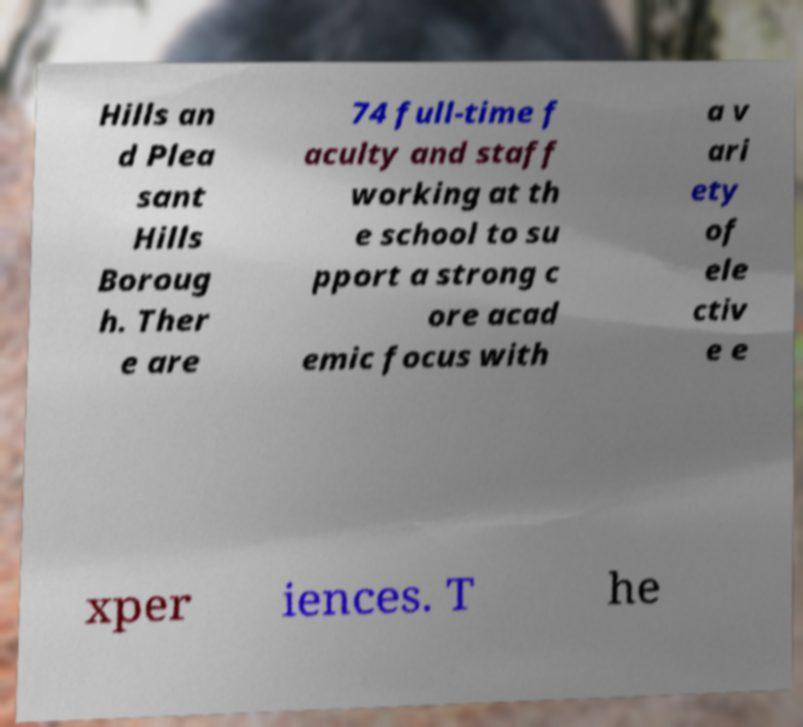Please read and relay the text visible in this image. What does it say? Hills an d Plea sant Hills Boroug h. Ther e are 74 full-time f aculty and staff working at th e school to su pport a strong c ore acad emic focus with a v ari ety of ele ctiv e e xper iences. T he 